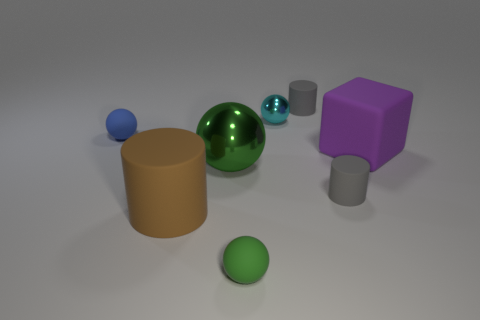Are there any large cyan cylinders made of the same material as the large purple object?
Make the answer very short. No. Is there a cyan metallic ball behind the small gray rubber thing that is behind the gray matte thing in front of the purple cube?
Make the answer very short. No. What number of other things are the same shape as the large brown thing?
Give a very brief answer. 2. There is a tiny rubber ball that is in front of the gray matte cylinder in front of the metallic sphere that is behind the green shiny thing; what is its color?
Offer a terse response. Green. What number of cyan cylinders are there?
Your response must be concise. 0. What number of big things are either purple matte cubes or blue matte things?
Your answer should be very brief. 1. What is the shape of the purple rubber thing that is the same size as the brown rubber thing?
Offer a very short reply. Cube. Is there anything else that has the same size as the green metal object?
Your answer should be very brief. Yes. There is a green sphere that is in front of the big rubber thing left of the purple cube; what is it made of?
Your response must be concise. Rubber. Do the brown object and the cyan metallic object have the same size?
Your answer should be very brief. No. 